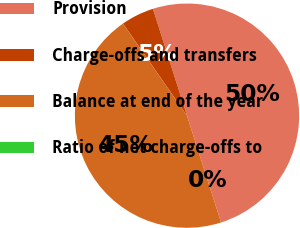Convert chart. <chart><loc_0><loc_0><loc_500><loc_500><pie_chart><fcel>Provision<fcel>Charge-offs and transfers<fcel>Balance at end of the year<fcel>Ratio of net charge-offs to<nl><fcel>50.0%<fcel>4.75%<fcel>45.25%<fcel>0.0%<nl></chart> 